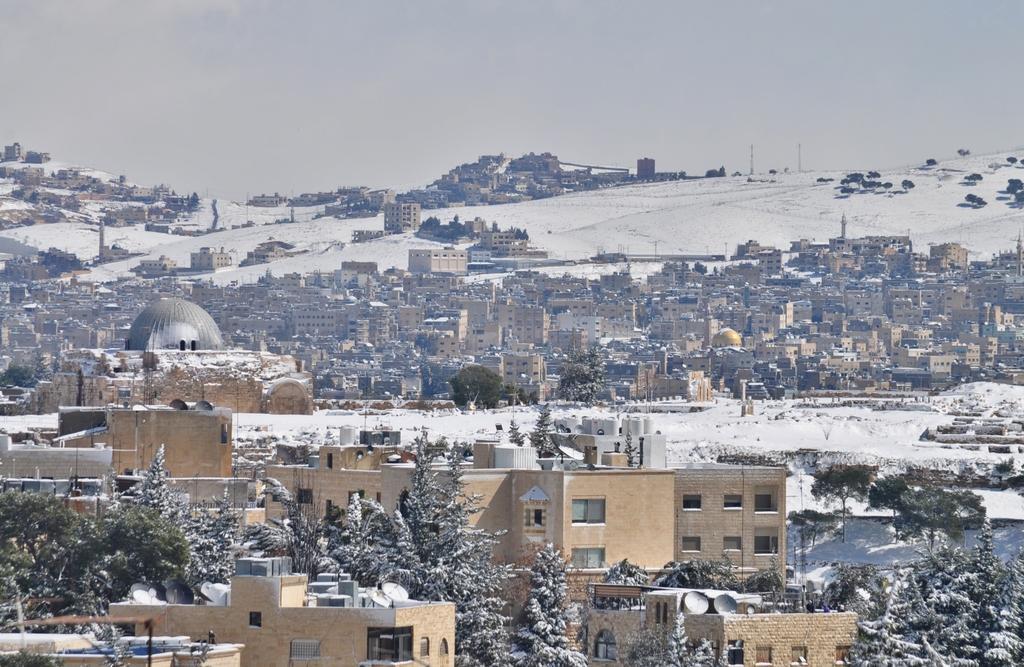In one or two sentences, can you explain what this image depicts? In this image, I can see the view of a city with the buildings and houses. This is a kind of a spire. I can see the trees, which are partially covered with the snow. This looks like a snow mountain. Here is the sky. 